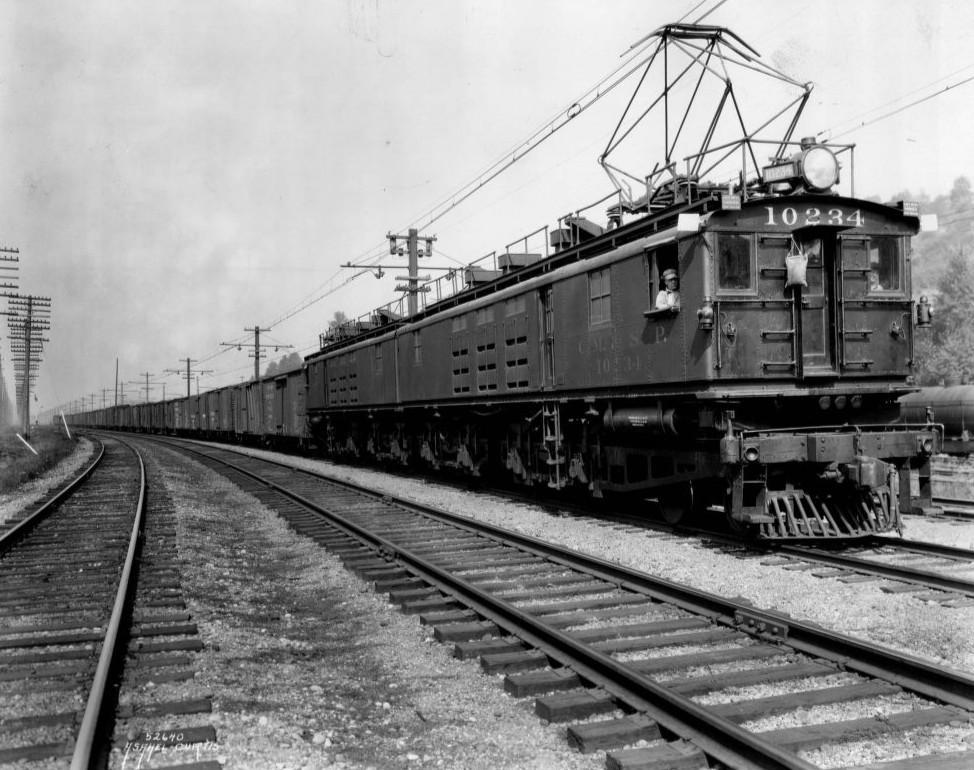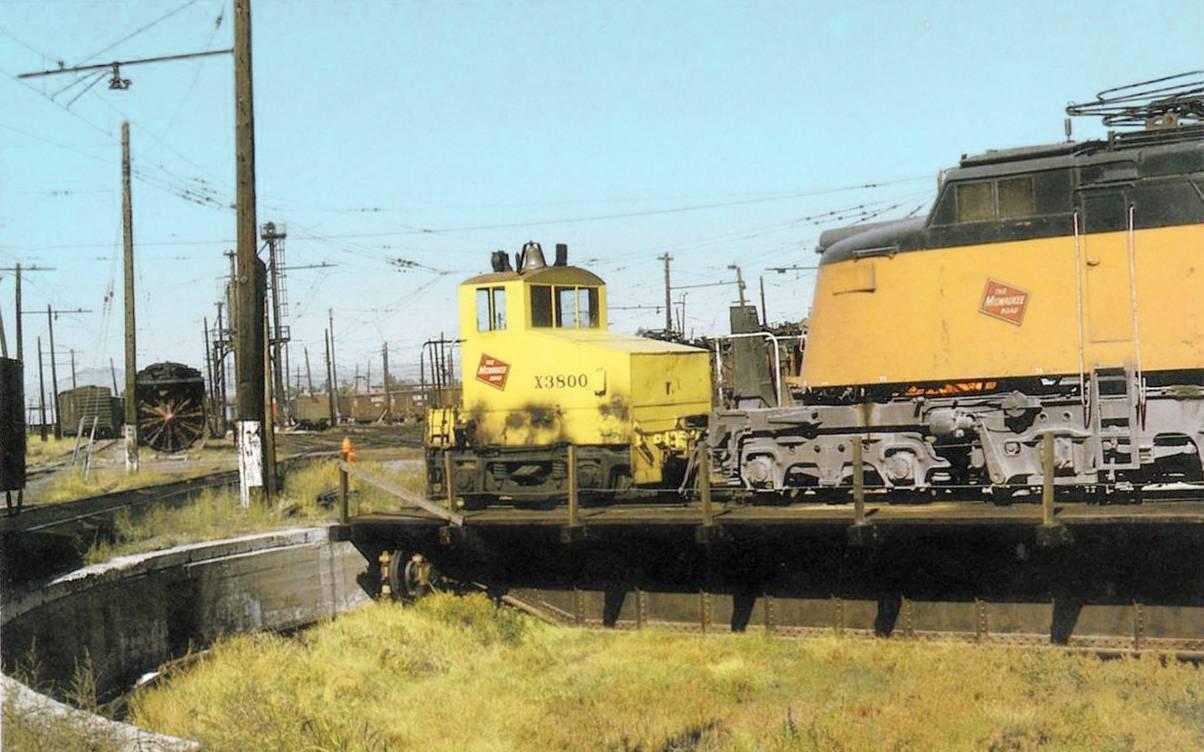The first image is the image on the left, the second image is the image on the right. For the images displayed, is the sentence "An image shows a rightward angled orange and black train, with no bridge extending over it." factually correct? Answer yes or no. No. The first image is the image on the left, the second image is the image on the right. Evaluate the accuracy of this statement regarding the images: "There is a yellow train with red markings in one of the images.". Is it true? Answer yes or no. Yes. 